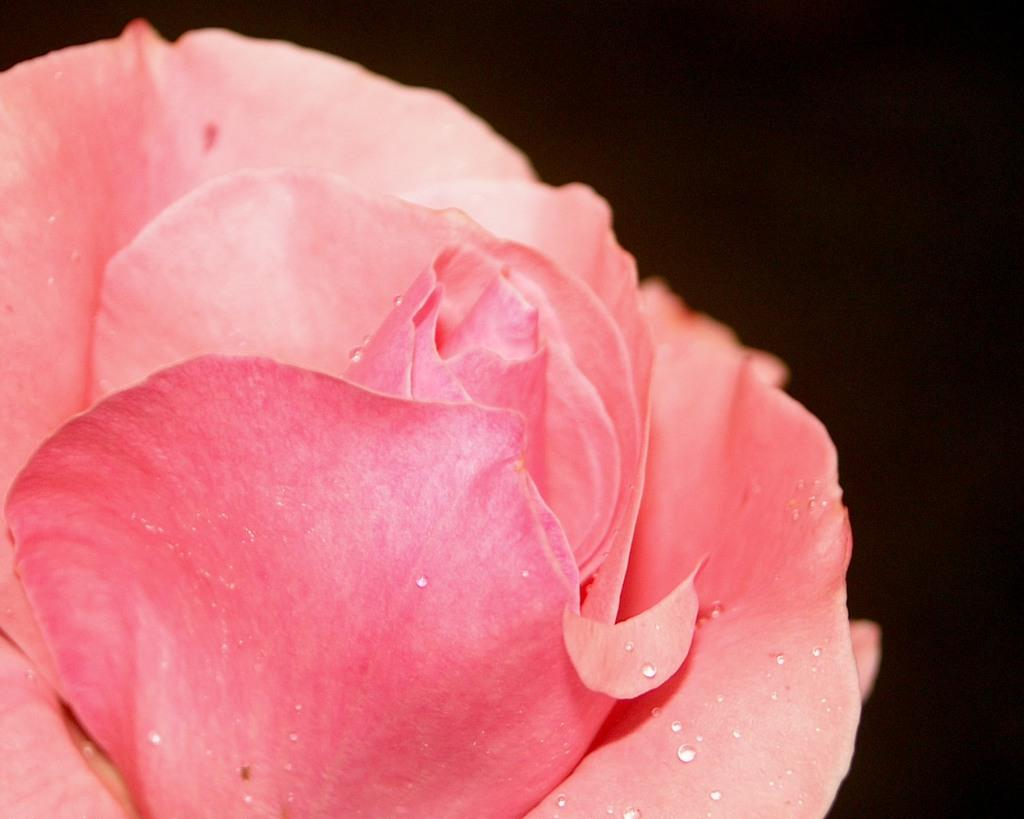What is the main subject of the image? The main subject of the image is a part of a flower. What color are the petals of the flower? The flower has pink petals. What can be observed about the background of the image? The background of the image is dark. What is the annual income of the flower in the image? There is no indication of income in the image, as flowers do not have an income. 